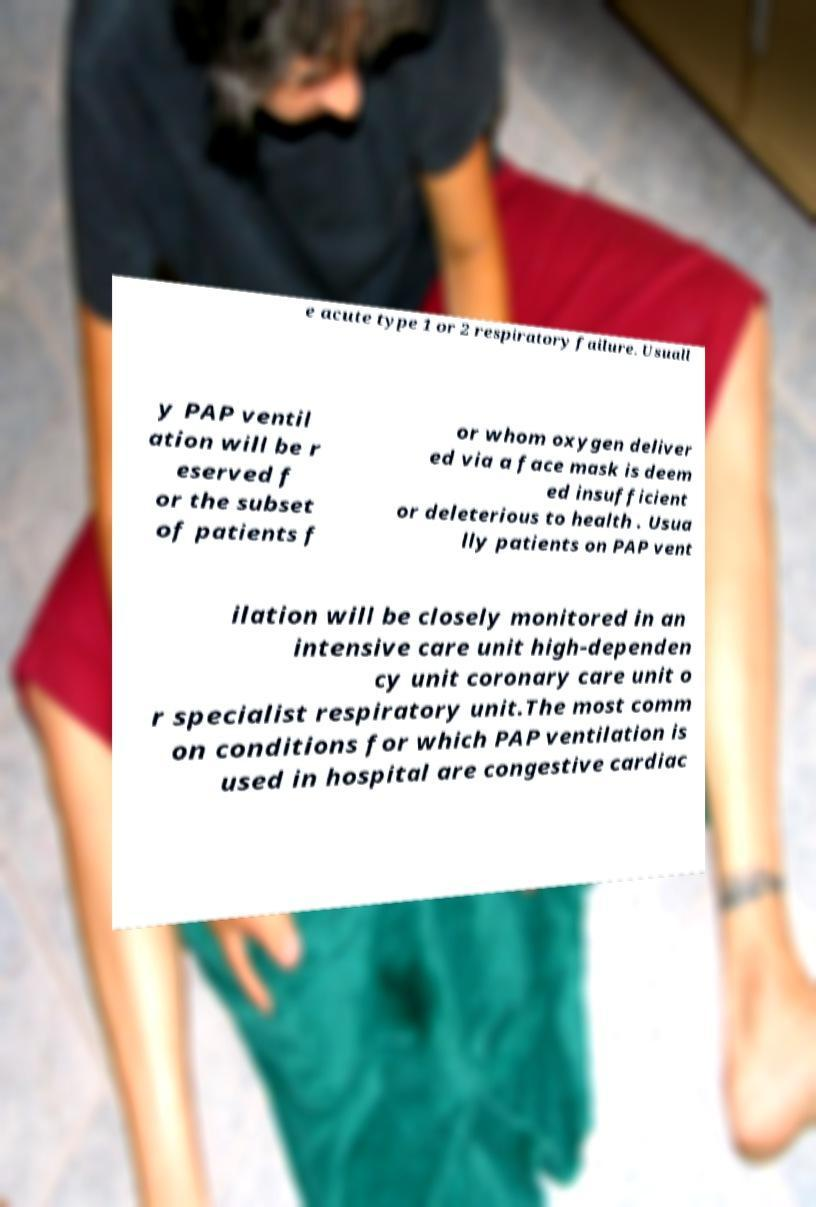Please identify and transcribe the text found in this image. e acute type 1 or 2 respiratory failure. Usuall y PAP ventil ation will be r eserved f or the subset of patients f or whom oxygen deliver ed via a face mask is deem ed insufficient or deleterious to health . Usua lly patients on PAP vent ilation will be closely monitored in an intensive care unit high-dependen cy unit coronary care unit o r specialist respiratory unit.The most comm on conditions for which PAP ventilation is used in hospital are congestive cardiac 